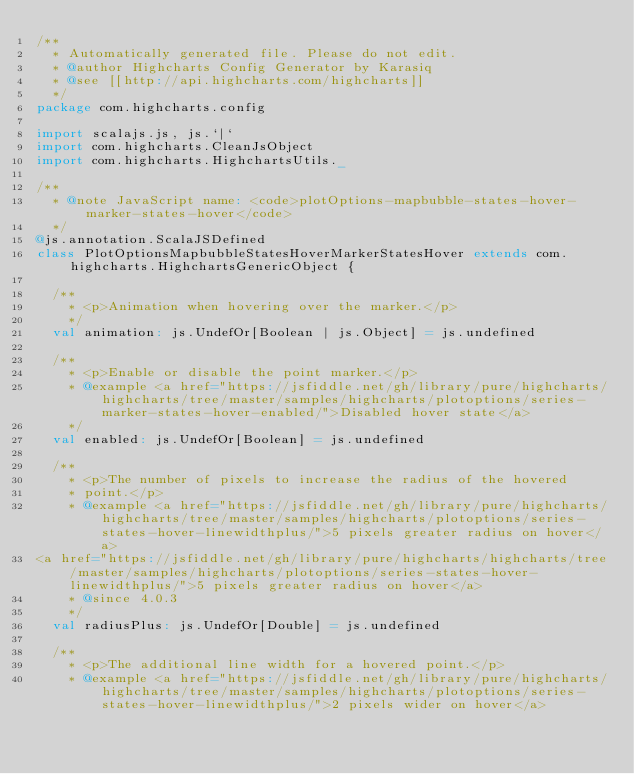<code> <loc_0><loc_0><loc_500><loc_500><_Scala_>/**
  * Automatically generated file. Please do not edit.
  * @author Highcharts Config Generator by Karasiq
  * @see [[http://api.highcharts.com/highcharts]]
  */
package com.highcharts.config

import scalajs.js, js.`|`
import com.highcharts.CleanJsObject
import com.highcharts.HighchartsUtils._

/**
  * @note JavaScript name: <code>plotOptions-mapbubble-states-hover-marker-states-hover</code>
  */
@js.annotation.ScalaJSDefined
class PlotOptionsMapbubbleStatesHoverMarkerStatesHover extends com.highcharts.HighchartsGenericObject {

  /**
    * <p>Animation when hovering over the marker.</p>
    */
  val animation: js.UndefOr[Boolean | js.Object] = js.undefined

  /**
    * <p>Enable or disable the point marker.</p>
    * @example <a href="https://jsfiddle.net/gh/library/pure/highcharts/highcharts/tree/master/samples/highcharts/plotoptions/series-marker-states-hover-enabled/">Disabled hover state</a>
    */
  val enabled: js.UndefOr[Boolean] = js.undefined

  /**
    * <p>The number of pixels to increase the radius of the hovered
    * point.</p>
    * @example <a href="https://jsfiddle.net/gh/library/pure/highcharts/highcharts/tree/master/samples/highcharts/plotoptions/series-states-hover-linewidthplus/">5 pixels greater radius on hover</a>
<a href="https://jsfiddle.net/gh/library/pure/highcharts/highcharts/tree/master/samples/highcharts/plotoptions/series-states-hover-linewidthplus/">5 pixels greater radius on hover</a>
    * @since 4.0.3
    */
  val radiusPlus: js.UndefOr[Double] = js.undefined

  /**
    * <p>The additional line width for a hovered point.</p>
    * @example <a href="https://jsfiddle.net/gh/library/pure/highcharts/highcharts/tree/master/samples/highcharts/plotoptions/series-states-hover-linewidthplus/">2 pixels wider on hover</a></code> 